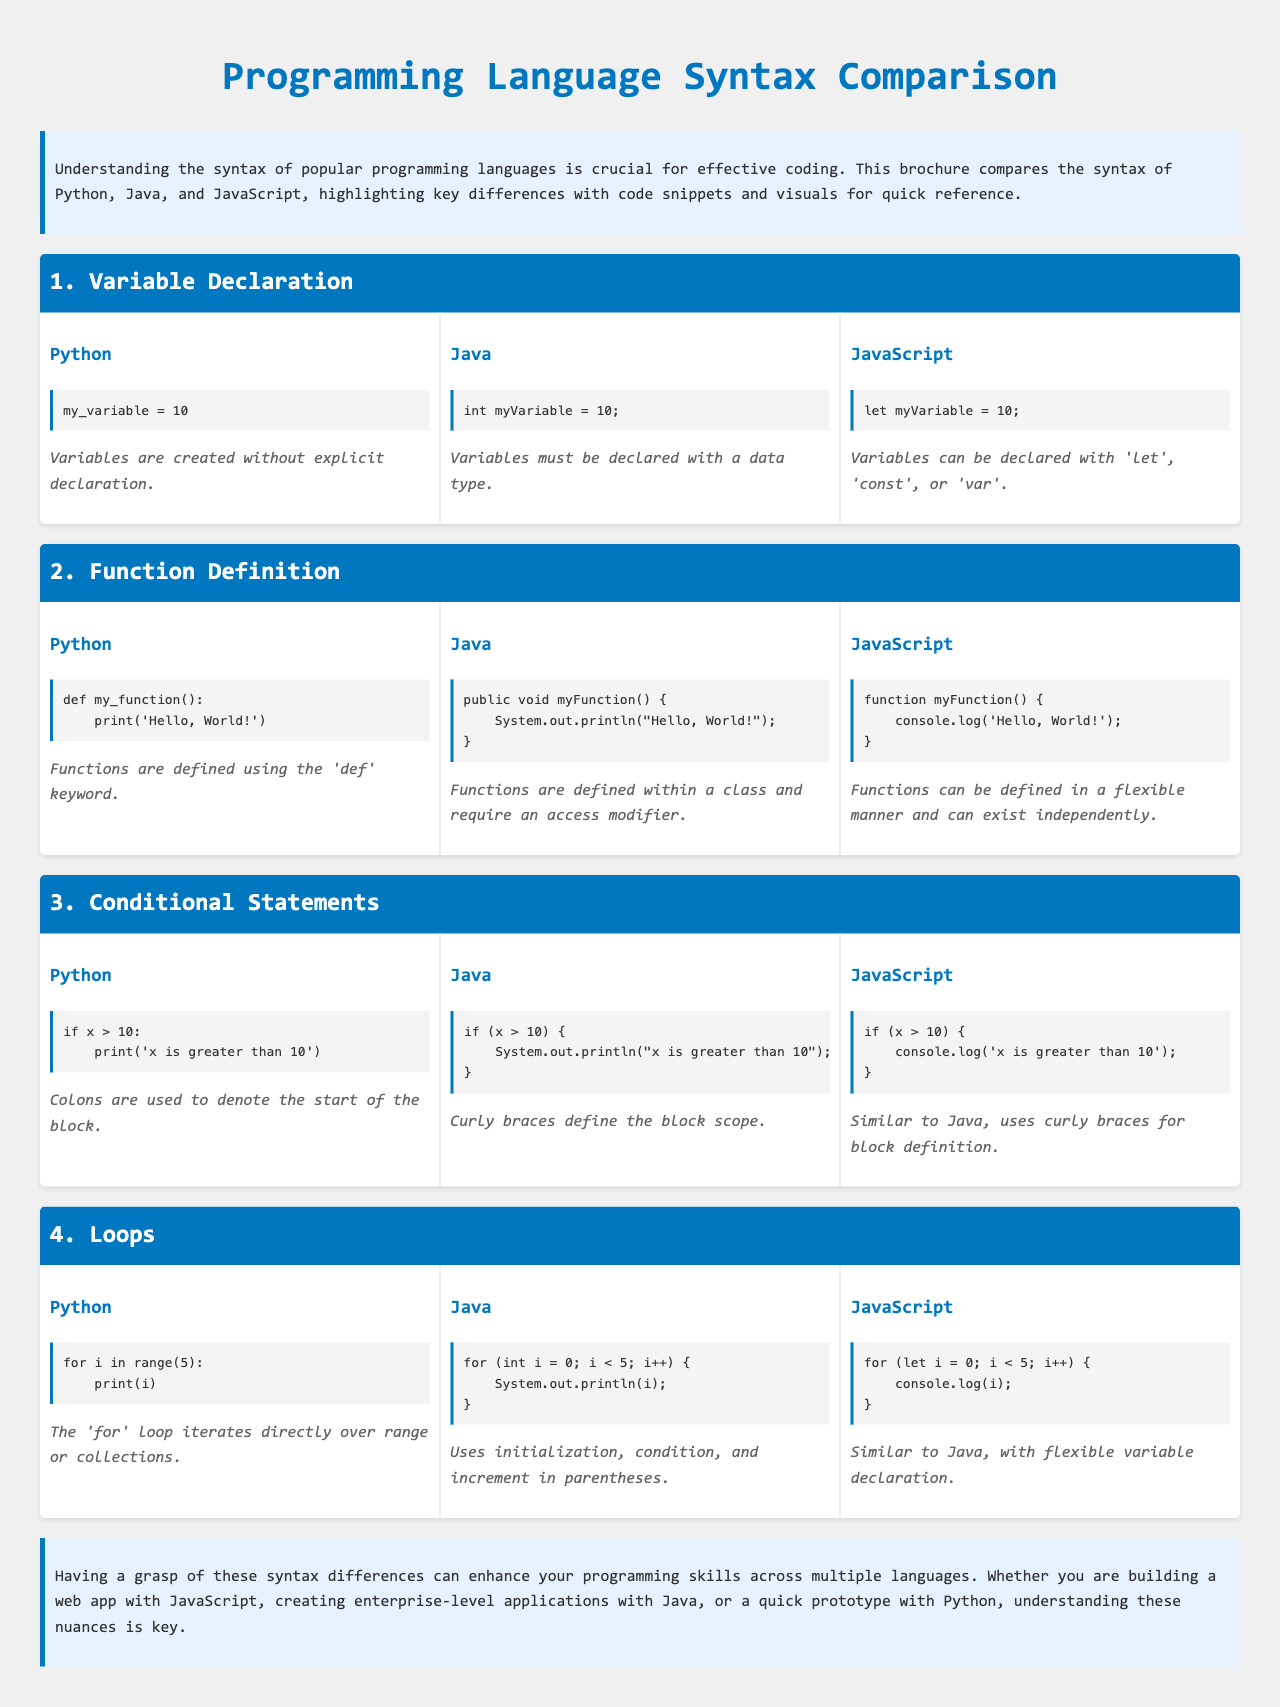What is the purpose of the brochure? The brochure aims to compare the syntax of popular programming languages, highlighting key differences for quick reference.
Answer: Compare syntax What keyword is used to define functions in Python? The document states that functions in Python are defined using the 'def' keyword.
Answer: def How many sections are dedicated to syntax comparison? There are four sections, each focusing on different syntax aspects across the languages.
Answer: Four What is the loop type highlighted for Python? The 'for' loop is specifically discussed in the Python section of the document.
Answer: for Which programming language requires an access modifier for function definitions? The document notes that Java requires an access modifier for function definitions.
Answer: Java What is the output statement used in JavaScript? The document indicates that JavaScript uses the 'console.log' statement for output.
Answer: console.log What visual styling is used for section titles? The section titles have a background color of blue and white text.
Answer: Blue background What punctuation denotes the block start in Python's conditional statements? The document describes that colons are used to denote the start of the block in Python.
Answer: Colon 